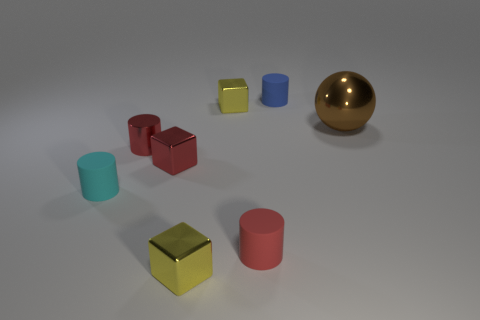What shape is the tiny matte object that is right of the shiny cylinder and in front of the large shiny thing? The tiny matte object located to the right of the shiny cylinder and in front of the large shiny sphere is a cube. 